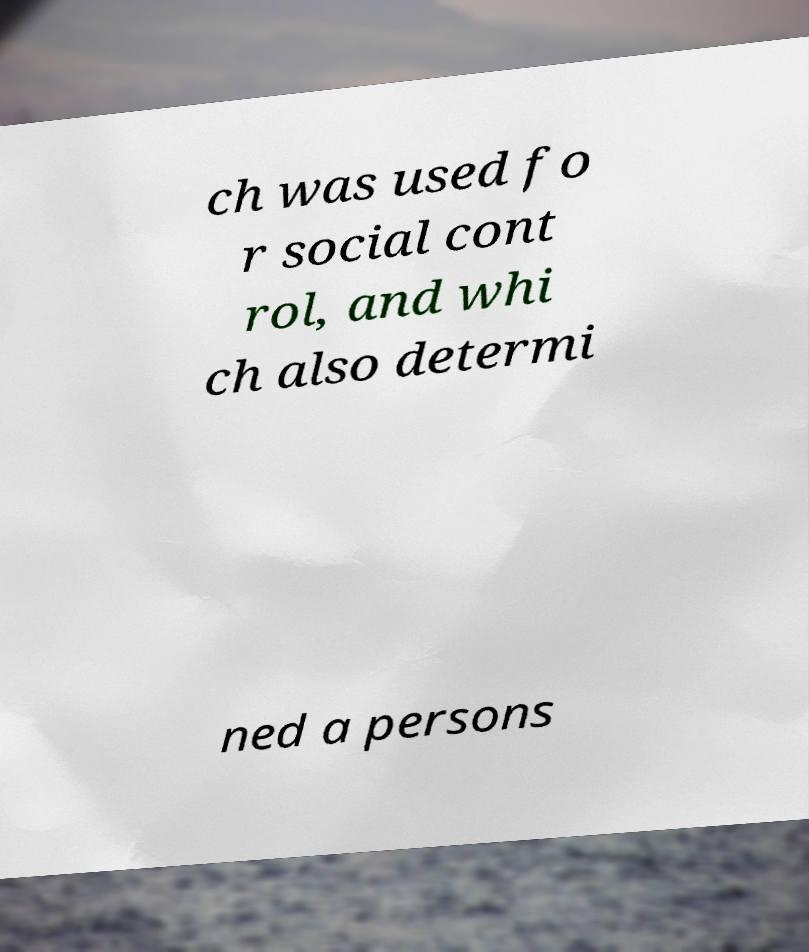For documentation purposes, I need the text within this image transcribed. Could you provide that? ch was used fo r social cont rol, and whi ch also determi ned a persons 